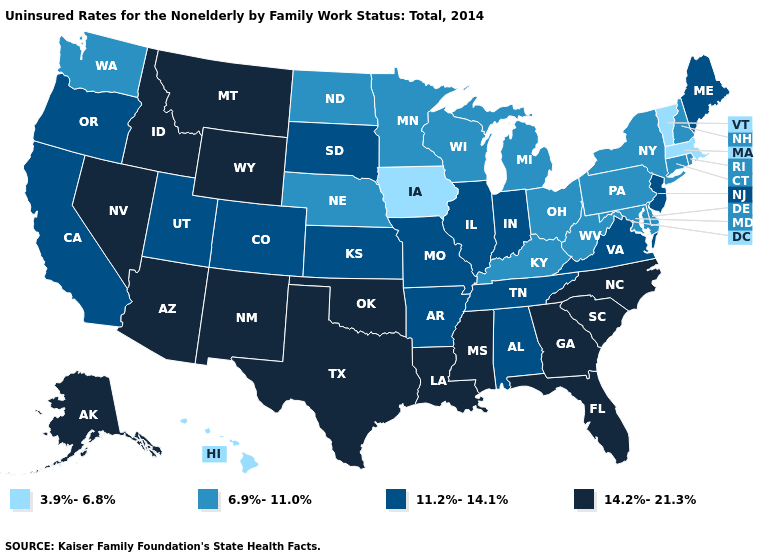Name the states that have a value in the range 11.2%-14.1%?
Write a very short answer. Alabama, Arkansas, California, Colorado, Illinois, Indiana, Kansas, Maine, Missouri, New Jersey, Oregon, South Dakota, Tennessee, Utah, Virginia. What is the value of Nevada?
Short answer required. 14.2%-21.3%. Among the states that border Utah , does Arizona have the lowest value?
Give a very brief answer. No. What is the value of Iowa?
Concise answer only. 3.9%-6.8%. Is the legend a continuous bar?
Keep it brief. No. How many symbols are there in the legend?
Concise answer only. 4. What is the highest value in states that border Delaware?
Short answer required. 11.2%-14.1%. Which states have the highest value in the USA?
Quick response, please. Alaska, Arizona, Florida, Georgia, Idaho, Louisiana, Mississippi, Montana, Nevada, New Mexico, North Carolina, Oklahoma, South Carolina, Texas, Wyoming. Which states hav the highest value in the South?
Give a very brief answer. Florida, Georgia, Louisiana, Mississippi, North Carolina, Oklahoma, South Carolina, Texas. Is the legend a continuous bar?
Write a very short answer. No. Does California have the highest value in the USA?
Give a very brief answer. No. Name the states that have a value in the range 3.9%-6.8%?
Answer briefly. Hawaii, Iowa, Massachusetts, Vermont. Does the first symbol in the legend represent the smallest category?
Give a very brief answer. Yes. Does Ohio have a lower value than Tennessee?
Answer briefly. Yes. 